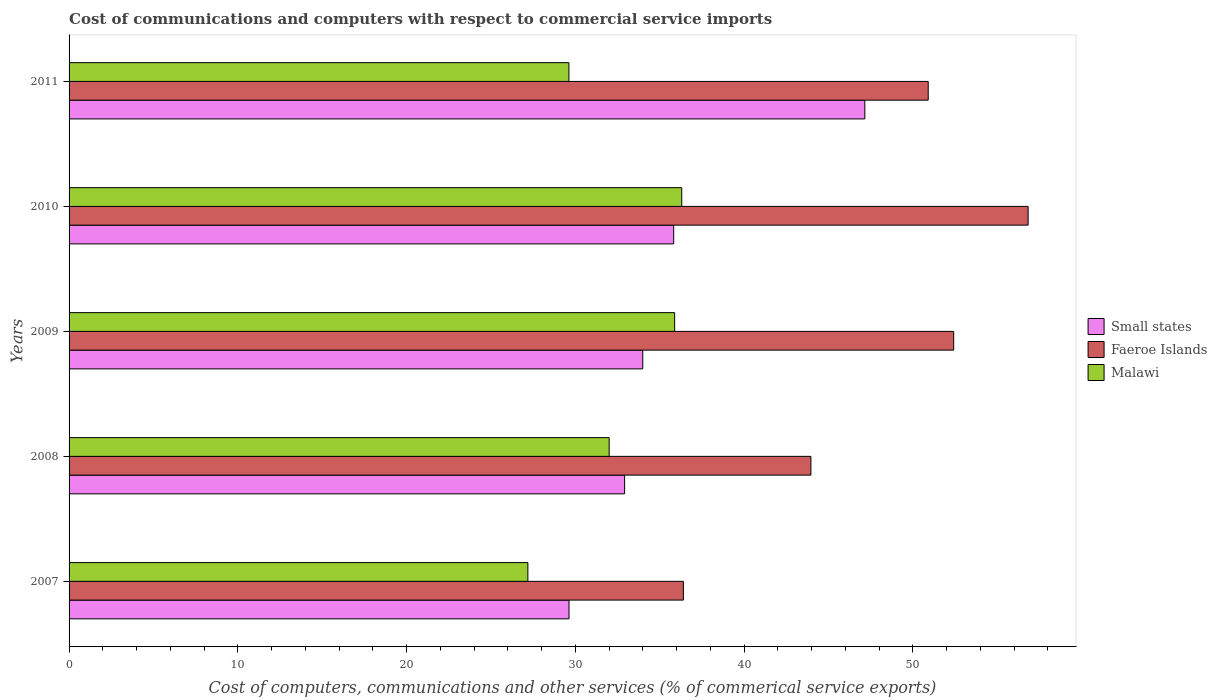How many different coloured bars are there?
Make the answer very short. 3. How many groups of bars are there?
Make the answer very short. 5. Are the number of bars per tick equal to the number of legend labels?
Offer a terse response. Yes. Are the number of bars on each tick of the Y-axis equal?
Your answer should be compact. Yes. How many bars are there on the 3rd tick from the top?
Provide a succinct answer. 3. In how many cases, is the number of bars for a given year not equal to the number of legend labels?
Your answer should be compact. 0. What is the cost of communications and computers in Small states in 2008?
Your answer should be very brief. 32.92. Across all years, what is the maximum cost of communications and computers in Faeroe Islands?
Provide a short and direct response. 56.83. Across all years, what is the minimum cost of communications and computers in Small states?
Provide a succinct answer. 29.62. What is the total cost of communications and computers in Faeroe Islands in the graph?
Provide a short and direct response. 240.51. What is the difference between the cost of communications and computers in Malawi in 2007 and that in 2010?
Offer a very short reply. -9.12. What is the difference between the cost of communications and computers in Malawi in 2008 and the cost of communications and computers in Small states in 2007?
Ensure brevity in your answer.  2.38. What is the average cost of communications and computers in Small states per year?
Provide a succinct answer. 35.9. In the year 2010, what is the difference between the cost of communications and computers in Faeroe Islands and cost of communications and computers in Malawi?
Give a very brief answer. 20.52. What is the ratio of the cost of communications and computers in Faeroe Islands in 2009 to that in 2010?
Offer a terse response. 0.92. Is the difference between the cost of communications and computers in Faeroe Islands in 2007 and 2011 greater than the difference between the cost of communications and computers in Malawi in 2007 and 2011?
Offer a very short reply. No. What is the difference between the highest and the second highest cost of communications and computers in Faeroe Islands?
Provide a short and direct response. 4.41. What is the difference between the highest and the lowest cost of communications and computers in Faeroe Islands?
Provide a short and direct response. 20.43. What does the 2nd bar from the top in 2010 represents?
Ensure brevity in your answer.  Faeroe Islands. What does the 3rd bar from the bottom in 2007 represents?
Offer a very short reply. Malawi. Is it the case that in every year, the sum of the cost of communications and computers in Small states and cost of communications and computers in Malawi is greater than the cost of communications and computers in Faeroe Islands?
Offer a terse response. Yes. How many bars are there?
Give a very brief answer. 15. What is the difference between two consecutive major ticks on the X-axis?
Your response must be concise. 10. Does the graph contain any zero values?
Give a very brief answer. No. Does the graph contain grids?
Ensure brevity in your answer.  No. How are the legend labels stacked?
Your response must be concise. Vertical. What is the title of the graph?
Provide a succinct answer. Cost of communications and computers with respect to commercial service imports. What is the label or title of the X-axis?
Keep it short and to the point. Cost of computers, communications and other services (% of commerical service exports). What is the label or title of the Y-axis?
Your answer should be very brief. Years. What is the Cost of computers, communications and other services (% of commerical service exports) of Small states in 2007?
Ensure brevity in your answer.  29.62. What is the Cost of computers, communications and other services (% of commerical service exports) in Faeroe Islands in 2007?
Your answer should be very brief. 36.4. What is the Cost of computers, communications and other services (% of commerical service exports) of Malawi in 2007?
Your answer should be compact. 27.19. What is the Cost of computers, communications and other services (% of commerical service exports) of Small states in 2008?
Your answer should be very brief. 32.92. What is the Cost of computers, communications and other services (% of commerical service exports) of Faeroe Islands in 2008?
Your answer should be compact. 43.96. What is the Cost of computers, communications and other services (% of commerical service exports) in Malawi in 2008?
Provide a succinct answer. 32. What is the Cost of computers, communications and other services (% of commerical service exports) of Small states in 2009?
Offer a very short reply. 33.99. What is the Cost of computers, communications and other services (% of commerical service exports) of Faeroe Islands in 2009?
Your response must be concise. 52.42. What is the Cost of computers, communications and other services (% of commerical service exports) in Malawi in 2009?
Provide a short and direct response. 35.88. What is the Cost of computers, communications and other services (% of commerical service exports) in Small states in 2010?
Provide a succinct answer. 35.83. What is the Cost of computers, communications and other services (% of commerical service exports) of Faeroe Islands in 2010?
Offer a very short reply. 56.83. What is the Cost of computers, communications and other services (% of commerical service exports) in Malawi in 2010?
Keep it short and to the point. 36.3. What is the Cost of computers, communications and other services (% of commerical service exports) of Small states in 2011?
Ensure brevity in your answer.  47.15. What is the Cost of computers, communications and other services (% of commerical service exports) of Faeroe Islands in 2011?
Give a very brief answer. 50.91. What is the Cost of computers, communications and other services (% of commerical service exports) of Malawi in 2011?
Offer a very short reply. 29.62. Across all years, what is the maximum Cost of computers, communications and other services (% of commerical service exports) of Small states?
Ensure brevity in your answer.  47.15. Across all years, what is the maximum Cost of computers, communications and other services (% of commerical service exports) in Faeroe Islands?
Offer a very short reply. 56.83. Across all years, what is the maximum Cost of computers, communications and other services (% of commerical service exports) of Malawi?
Make the answer very short. 36.3. Across all years, what is the minimum Cost of computers, communications and other services (% of commerical service exports) in Small states?
Provide a succinct answer. 29.62. Across all years, what is the minimum Cost of computers, communications and other services (% of commerical service exports) of Faeroe Islands?
Your response must be concise. 36.4. Across all years, what is the minimum Cost of computers, communications and other services (% of commerical service exports) of Malawi?
Provide a short and direct response. 27.19. What is the total Cost of computers, communications and other services (% of commerical service exports) in Small states in the graph?
Your answer should be compact. 179.51. What is the total Cost of computers, communications and other services (% of commerical service exports) in Faeroe Islands in the graph?
Provide a short and direct response. 240.51. What is the total Cost of computers, communications and other services (% of commerical service exports) of Malawi in the graph?
Your answer should be compact. 160.99. What is the difference between the Cost of computers, communications and other services (% of commerical service exports) of Small states in 2007 and that in 2008?
Your answer should be very brief. -3.29. What is the difference between the Cost of computers, communications and other services (% of commerical service exports) in Faeroe Islands in 2007 and that in 2008?
Make the answer very short. -7.56. What is the difference between the Cost of computers, communications and other services (% of commerical service exports) in Malawi in 2007 and that in 2008?
Provide a short and direct response. -4.82. What is the difference between the Cost of computers, communications and other services (% of commerical service exports) in Small states in 2007 and that in 2009?
Offer a very short reply. -4.37. What is the difference between the Cost of computers, communications and other services (% of commerical service exports) in Faeroe Islands in 2007 and that in 2009?
Your answer should be compact. -16.02. What is the difference between the Cost of computers, communications and other services (% of commerical service exports) in Malawi in 2007 and that in 2009?
Offer a terse response. -8.7. What is the difference between the Cost of computers, communications and other services (% of commerical service exports) in Small states in 2007 and that in 2010?
Make the answer very short. -6.2. What is the difference between the Cost of computers, communications and other services (% of commerical service exports) in Faeroe Islands in 2007 and that in 2010?
Give a very brief answer. -20.43. What is the difference between the Cost of computers, communications and other services (% of commerical service exports) in Malawi in 2007 and that in 2010?
Make the answer very short. -9.12. What is the difference between the Cost of computers, communications and other services (% of commerical service exports) in Small states in 2007 and that in 2011?
Ensure brevity in your answer.  -17.53. What is the difference between the Cost of computers, communications and other services (% of commerical service exports) in Faeroe Islands in 2007 and that in 2011?
Your response must be concise. -14.51. What is the difference between the Cost of computers, communications and other services (% of commerical service exports) in Malawi in 2007 and that in 2011?
Give a very brief answer. -2.43. What is the difference between the Cost of computers, communications and other services (% of commerical service exports) of Small states in 2008 and that in 2009?
Ensure brevity in your answer.  -1.08. What is the difference between the Cost of computers, communications and other services (% of commerical service exports) in Faeroe Islands in 2008 and that in 2009?
Your response must be concise. -8.46. What is the difference between the Cost of computers, communications and other services (% of commerical service exports) in Malawi in 2008 and that in 2009?
Give a very brief answer. -3.88. What is the difference between the Cost of computers, communications and other services (% of commerical service exports) in Small states in 2008 and that in 2010?
Keep it short and to the point. -2.91. What is the difference between the Cost of computers, communications and other services (% of commerical service exports) in Faeroe Islands in 2008 and that in 2010?
Give a very brief answer. -12.87. What is the difference between the Cost of computers, communications and other services (% of commerical service exports) of Malawi in 2008 and that in 2010?
Your answer should be very brief. -4.3. What is the difference between the Cost of computers, communications and other services (% of commerical service exports) in Small states in 2008 and that in 2011?
Make the answer very short. -14.23. What is the difference between the Cost of computers, communications and other services (% of commerical service exports) in Faeroe Islands in 2008 and that in 2011?
Keep it short and to the point. -6.95. What is the difference between the Cost of computers, communications and other services (% of commerical service exports) in Malawi in 2008 and that in 2011?
Offer a terse response. 2.39. What is the difference between the Cost of computers, communications and other services (% of commerical service exports) in Small states in 2009 and that in 2010?
Provide a short and direct response. -1.83. What is the difference between the Cost of computers, communications and other services (% of commerical service exports) in Faeroe Islands in 2009 and that in 2010?
Provide a succinct answer. -4.41. What is the difference between the Cost of computers, communications and other services (% of commerical service exports) in Malawi in 2009 and that in 2010?
Keep it short and to the point. -0.42. What is the difference between the Cost of computers, communications and other services (% of commerical service exports) in Small states in 2009 and that in 2011?
Your answer should be very brief. -13.16. What is the difference between the Cost of computers, communications and other services (% of commerical service exports) of Faeroe Islands in 2009 and that in 2011?
Your answer should be compact. 1.51. What is the difference between the Cost of computers, communications and other services (% of commerical service exports) of Malawi in 2009 and that in 2011?
Ensure brevity in your answer.  6.26. What is the difference between the Cost of computers, communications and other services (% of commerical service exports) of Small states in 2010 and that in 2011?
Your response must be concise. -11.33. What is the difference between the Cost of computers, communications and other services (% of commerical service exports) in Faeroe Islands in 2010 and that in 2011?
Keep it short and to the point. 5.92. What is the difference between the Cost of computers, communications and other services (% of commerical service exports) of Malawi in 2010 and that in 2011?
Provide a short and direct response. 6.68. What is the difference between the Cost of computers, communications and other services (% of commerical service exports) in Small states in 2007 and the Cost of computers, communications and other services (% of commerical service exports) in Faeroe Islands in 2008?
Provide a short and direct response. -14.33. What is the difference between the Cost of computers, communications and other services (% of commerical service exports) in Small states in 2007 and the Cost of computers, communications and other services (% of commerical service exports) in Malawi in 2008?
Ensure brevity in your answer.  -2.38. What is the difference between the Cost of computers, communications and other services (% of commerical service exports) in Faeroe Islands in 2007 and the Cost of computers, communications and other services (% of commerical service exports) in Malawi in 2008?
Your response must be concise. 4.4. What is the difference between the Cost of computers, communications and other services (% of commerical service exports) of Small states in 2007 and the Cost of computers, communications and other services (% of commerical service exports) of Faeroe Islands in 2009?
Your answer should be very brief. -22.79. What is the difference between the Cost of computers, communications and other services (% of commerical service exports) in Small states in 2007 and the Cost of computers, communications and other services (% of commerical service exports) in Malawi in 2009?
Your answer should be compact. -6.26. What is the difference between the Cost of computers, communications and other services (% of commerical service exports) in Faeroe Islands in 2007 and the Cost of computers, communications and other services (% of commerical service exports) in Malawi in 2009?
Keep it short and to the point. 0.52. What is the difference between the Cost of computers, communications and other services (% of commerical service exports) in Small states in 2007 and the Cost of computers, communications and other services (% of commerical service exports) in Faeroe Islands in 2010?
Provide a succinct answer. -27.2. What is the difference between the Cost of computers, communications and other services (% of commerical service exports) in Small states in 2007 and the Cost of computers, communications and other services (% of commerical service exports) in Malawi in 2010?
Provide a succinct answer. -6.68. What is the difference between the Cost of computers, communications and other services (% of commerical service exports) in Faeroe Islands in 2007 and the Cost of computers, communications and other services (% of commerical service exports) in Malawi in 2010?
Your answer should be very brief. 0.1. What is the difference between the Cost of computers, communications and other services (% of commerical service exports) of Small states in 2007 and the Cost of computers, communications and other services (% of commerical service exports) of Faeroe Islands in 2011?
Your answer should be very brief. -21.28. What is the difference between the Cost of computers, communications and other services (% of commerical service exports) of Small states in 2007 and the Cost of computers, communications and other services (% of commerical service exports) of Malawi in 2011?
Give a very brief answer. 0.01. What is the difference between the Cost of computers, communications and other services (% of commerical service exports) of Faeroe Islands in 2007 and the Cost of computers, communications and other services (% of commerical service exports) of Malawi in 2011?
Keep it short and to the point. 6.78. What is the difference between the Cost of computers, communications and other services (% of commerical service exports) of Small states in 2008 and the Cost of computers, communications and other services (% of commerical service exports) of Faeroe Islands in 2009?
Give a very brief answer. -19.5. What is the difference between the Cost of computers, communications and other services (% of commerical service exports) in Small states in 2008 and the Cost of computers, communications and other services (% of commerical service exports) in Malawi in 2009?
Give a very brief answer. -2.97. What is the difference between the Cost of computers, communications and other services (% of commerical service exports) of Faeroe Islands in 2008 and the Cost of computers, communications and other services (% of commerical service exports) of Malawi in 2009?
Ensure brevity in your answer.  8.07. What is the difference between the Cost of computers, communications and other services (% of commerical service exports) of Small states in 2008 and the Cost of computers, communications and other services (% of commerical service exports) of Faeroe Islands in 2010?
Your response must be concise. -23.91. What is the difference between the Cost of computers, communications and other services (% of commerical service exports) in Small states in 2008 and the Cost of computers, communications and other services (% of commerical service exports) in Malawi in 2010?
Your answer should be compact. -3.39. What is the difference between the Cost of computers, communications and other services (% of commerical service exports) in Faeroe Islands in 2008 and the Cost of computers, communications and other services (% of commerical service exports) in Malawi in 2010?
Provide a short and direct response. 7.65. What is the difference between the Cost of computers, communications and other services (% of commerical service exports) of Small states in 2008 and the Cost of computers, communications and other services (% of commerical service exports) of Faeroe Islands in 2011?
Provide a short and direct response. -17.99. What is the difference between the Cost of computers, communications and other services (% of commerical service exports) of Small states in 2008 and the Cost of computers, communications and other services (% of commerical service exports) of Malawi in 2011?
Provide a succinct answer. 3.3. What is the difference between the Cost of computers, communications and other services (% of commerical service exports) of Faeroe Islands in 2008 and the Cost of computers, communications and other services (% of commerical service exports) of Malawi in 2011?
Make the answer very short. 14.34. What is the difference between the Cost of computers, communications and other services (% of commerical service exports) of Small states in 2009 and the Cost of computers, communications and other services (% of commerical service exports) of Faeroe Islands in 2010?
Ensure brevity in your answer.  -22.83. What is the difference between the Cost of computers, communications and other services (% of commerical service exports) in Small states in 2009 and the Cost of computers, communications and other services (% of commerical service exports) in Malawi in 2010?
Provide a succinct answer. -2.31. What is the difference between the Cost of computers, communications and other services (% of commerical service exports) of Faeroe Islands in 2009 and the Cost of computers, communications and other services (% of commerical service exports) of Malawi in 2010?
Keep it short and to the point. 16.11. What is the difference between the Cost of computers, communications and other services (% of commerical service exports) in Small states in 2009 and the Cost of computers, communications and other services (% of commerical service exports) in Faeroe Islands in 2011?
Your answer should be very brief. -16.91. What is the difference between the Cost of computers, communications and other services (% of commerical service exports) of Small states in 2009 and the Cost of computers, communications and other services (% of commerical service exports) of Malawi in 2011?
Provide a succinct answer. 4.38. What is the difference between the Cost of computers, communications and other services (% of commerical service exports) in Faeroe Islands in 2009 and the Cost of computers, communications and other services (% of commerical service exports) in Malawi in 2011?
Your answer should be compact. 22.8. What is the difference between the Cost of computers, communications and other services (% of commerical service exports) of Small states in 2010 and the Cost of computers, communications and other services (% of commerical service exports) of Faeroe Islands in 2011?
Make the answer very short. -15.08. What is the difference between the Cost of computers, communications and other services (% of commerical service exports) of Small states in 2010 and the Cost of computers, communications and other services (% of commerical service exports) of Malawi in 2011?
Offer a very short reply. 6.21. What is the difference between the Cost of computers, communications and other services (% of commerical service exports) of Faeroe Islands in 2010 and the Cost of computers, communications and other services (% of commerical service exports) of Malawi in 2011?
Your response must be concise. 27.21. What is the average Cost of computers, communications and other services (% of commerical service exports) in Small states per year?
Provide a succinct answer. 35.9. What is the average Cost of computers, communications and other services (% of commerical service exports) of Faeroe Islands per year?
Provide a short and direct response. 48.1. What is the average Cost of computers, communications and other services (% of commerical service exports) in Malawi per year?
Provide a succinct answer. 32.2. In the year 2007, what is the difference between the Cost of computers, communications and other services (% of commerical service exports) in Small states and Cost of computers, communications and other services (% of commerical service exports) in Faeroe Islands?
Give a very brief answer. -6.78. In the year 2007, what is the difference between the Cost of computers, communications and other services (% of commerical service exports) in Small states and Cost of computers, communications and other services (% of commerical service exports) in Malawi?
Offer a very short reply. 2.44. In the year 2007, what is the difference between the Cost of computers, communications and other services (% of commerical service exports) in Faeroe Islands and Cost of computers, communications and other services (% of commerical service exports) in Malawi?
Your response must be concise. 9.21. In the year 2008, what is the difference between the Cost of computers, communications and other services (% of commerical service exports) of Small states and Cost of computers, communications and other services (% of commerical service exports) of Faeroe Islands?
Provide a short and direct response. -11.04. In the year 2008, what is the difference between the Cost of computers, communications and other services (% of commerical service exports) in Small states and Cost of computers, communications and other services (% of commerical service exports) in Malawi?
Your answer should be compact. 0.91. In the year 2008, what is the difference between the Cost of computers, communications and other services (% of commerical service exports) in Faeroe Islands and Cost of computers, communications and other services (% of commerical service exports) in Malawi?
Ensure brevity in your answer.  11.95. In the year 2009, what is the difference between the Cost of computers, communications and other services (% of commerical service exports) of Small states and Cost of computers, communications and other services (% of commerical service exports) of Faeroe Islands?
Offer a terse response. -18.42. In the year 2009, what is the difference between the Cost of computers, communications and other services (% of commerical service exports) of Small states and Cost of computers, communications and other services (% of commerical service exports) of Malawi?
Your answer should be very brief. -1.89. In the year 2009, what is the difference between the Cost of computers, communications and other services (% of commerical service exports) in Faeroe Islands and Cost of computers, communications and other services (% of commerical service exports) in Malawi?
Give a very brief answer. 16.53. In the year 2010, what is the difference between the Cost of computers, communications and other services (% of commerical service exports) in Small states and Cost of computers, communications and other services (% of commerical service exports) in Faeroe Islands?
Keep it short and to the point. -21. In the year 2010, what is the difference between the Cost of computers, communications and other services (% of commerical service exports) of Small states and Cost of computers, communications and other services (% of commerical service exports) of Malawi?
Offer a terse response. -0.48. In the year 2010, what is the difference between the Cost of computers, communications and other services (% of commerical service exports) of Faeroe Islands and Cost of computers, communications and other services (% of commerical service exports) of Malawi?
Make the answer very short. 20.52. In the year 2011, what is the difference between the Cost of computers, communications and other services (% of commerical service exports) of Small states and Cost of computers, communications and other services (% of commerical service exports) of Faeroe Islands?
Your response must be concise. -3.76. In the year 2011, what is the difference between the Cost of computers, communications and other services (% of commerical service exports) in Small states and Cost of computers, communications and other services (% of commerical service exports) in Malawi?
Give a very brief answer. 17.53. In the year 2011, what is the difference between the Cost of computers, communications and other services (% of commerical service exports) of Faeroe Islands and Cost of computers, communications and other services (% of commerical service exports) of Malawi?
Provide a succinct answer. 21.29. What is the ratio of the Cost of computers, communications and other services (% of commerical service exports) of Small states in 2007 to that in 2008?
Your answer should be compact. 0.9. What is the ratio of the Cost of computers, communications and other services (% of commerical service exports) in Faeroe Islands in 2007 to that in 2008?
Ensure brevity in your answer.  0.83. What is the ratio of the Cost of computers, communications and other services (% of commerical service exports) in Malawi in 2007 to that in 2008?
Provide a short and direct response. 0.85. What is the ratio of the Cost of computers, communications and other services (% of commerical service exports) in Small states in 2007 to that in 2009?
Provide a succinct answer. 0.87. What is the ratio of the Cost of computers, communications and other services (% of commerical service exports) of Faeroe Islands in 2007 to that in 2009?
Ensure brevity in your answer.  0.69. What is the ratio of the Cost of computers, communications and other services (% of commerical service exports) of Malawi in 2007 to that in 2009?
Make the answer very short. 0.76. What is the ratio of the Cost of computers, communications and other services (% of commerical service exports) in Small states in 2007 to that in 2010?
Make the answer very short. 0.83. What is the ratio of the Cost of computers, communications and other services (% of commerical service exports) of Faeroe Islands in 2007 to that in 2010?
Your answer should be compact. 0.64. What is the ratio of the Cost of computers, communications and other services (% of commerical service exports) of Malawi in 2007 to that in 2010?
Ensure brevity in your answer.  0.75. What is the ratio of the Cost of computers, communications and other services (% of commerical service exports) of Small states in 2007 to that in 2011?
Your response must be concise. 0.63. What is the ratio of the Cost of computers, communications and other services (% of commerical service exports) in Faeroe Islands in 2007 to that in 2011?
Your answer should be compact. 0.71. What is the ratio of the Cost of computers, communications and other services (% of commerical service exports) of Malawi in 2007 to that in 2011?
Your response must be concise. 0.92. What is the ratio of the Cost of computers, communications and other services (% of commerical service exports) in Small states in 2008 to that in 2009?
Offer a very short reply. 0.97. What is the ratio of the Cost of computers, communications and other services (% of commerical service exports) in Faeroe Islands in 2008 to that in 2009?
Make the answer very short. 0.84. What is the ratio of the Cost of computers, communications and other services (% of commerical service exports) in Malawi in 2008 to that in 2009?
Your answer should be compact. 0.89. What is the ratio of the Cost of computers, communications and other services (% of commerical service exports) in Small states in 2008 to that in 2010?
Give a very brief answer. 0.92. What is the ratio of the Cost of computers, communications and other services (% of commerical service exports) of Faeroe Islands in 2008 to that in 2010?
Keep it short and to the point. 0.77. What is the ratio of the Cost of computers, communications and other services (% of commerical service exports) in Malawi in 2008 to that in 2010?
Ensure brevity in your answer.  0.88. What is the ratio of the Cost of computers, communications and other services (% of commerical service exports) of Small states in 2008 to that in 2011?
Your answer should be compact. 0.7. What is the ratio of the Cost of computers, communications and other services (% of commerical service exports) in Faeroe Islands in 2008 to that in 2011?
Give a very brief answer. 0.86. What is the ratio of the Cost of computers, communications and other services (% of commerical service exports) of Malawi in 2008 to that in 2011?
Keep it short and to the point. 1.08. What is the ratio of the Cost of computers, communications and other services (% of commerical service exports) in Small states in 2009 to that in 2010?
Give a very brief answer. 0.95. What is the ratio of the Cost of computers, communications and other services (% of commerical service exports) in Faeroe Islands in 2009 to that in 2010?
Ensure brevity in your answer.  0.92. What is the ratio of the Cost of computers, communications and other services (% of commerical service exports) of Malawi in 2009 to that in 2010?
Your answer should be compact. 0.99. What is the ratio of the Cost of computers, communications and other services (% of commerical service exports) in Small states in 2009 to that in 2011?
Your response must be concise. 0.72. What is the ratio of the Cost of computers, communications and other services (% of commerical service exports) of Faeroe Islands in 2009 to that in 2011?
Your response must be concise. 1.03. What is the ratio of the Cost of computers, communications and other services (% of commerical service exports) of Malawi in 2009 to that in 2011?
Provide a succinct answer. 1.21. What is the ratio of the Cost of computers, communications and other services (% of commerical service exports) of Small states in 2010 to that in 2011?
Your answer should be very brief. 0.76. What is the ratio of the Cost of computers, communications and other services (% of commerical service exports) in Faeroe Islands in 2010 to that in 2011?
Provide a short and direct response. 1.12. What is the ratio of the Cost of computers, communications and other services (% of commerical service exports) in Malawi in 2010 to that in 2011?
Your answer should be very brief. 1.23. What is the difference between the highest and the second highest Cost of computers, communications and other services (% of commerical service exports) of Small states?
Offer a terse response. 11.33. What is the difference between the highest and the second highest Cost of computers, communications and other services (% of commerical service exports) in Faeroe Islands?
Your answer should be very brief. 4.41. What is the difference between the highest and the second highest Cost of computers, communications and other services (% of commerical service exports) in Malawi?
Provide a short and direct response. 0.42. What is the difference between the highest and the lowest Cost of computers, communications and other services (% of commerical service exports) of Small states?
Ensure brevity in your answer.  17.53. What is the difference between the highest and the lowest Cost of computers, communications and other services (% of commerical service exports) of Faeroe Islands?
Make the answer very short. 20.43. What is the difference between the highest and the lowest Cost of computers, communications and other services (% of commerical service exports) in Malawi?
Keep it short and to the point. 9.12. 